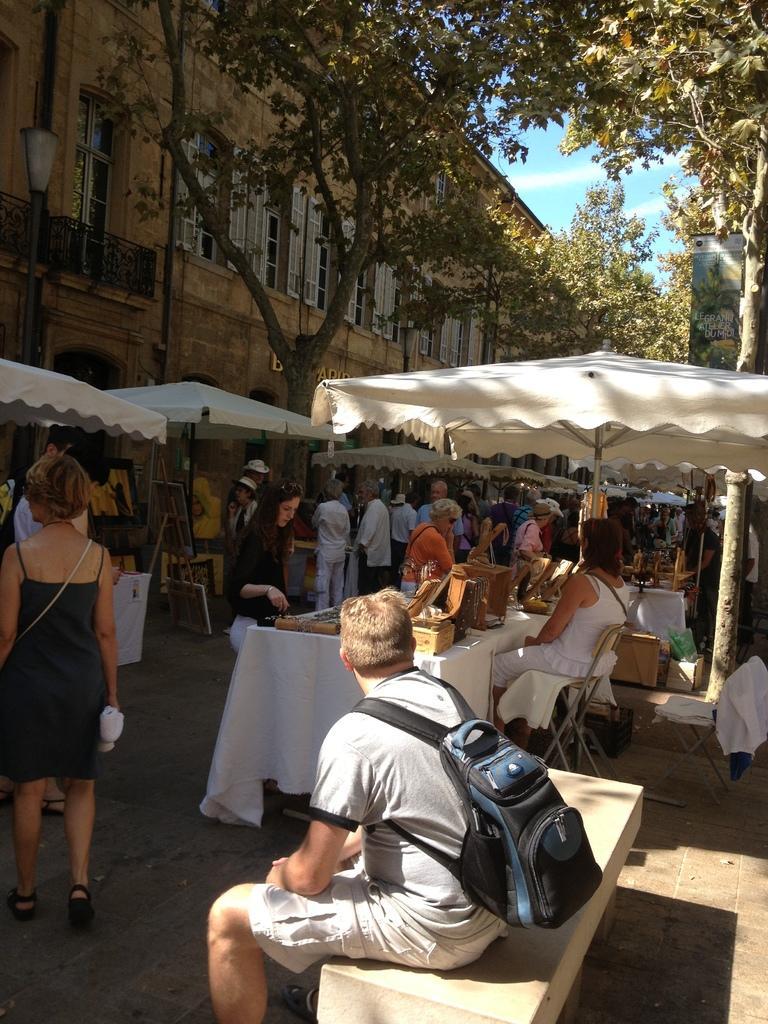Can you describe this image briefly? There is a building at one side behind a tree and there are few tents placed on roads lot of crowd watching the stalls and stuff in it. there is man sitting on bench wearing a backpack. 